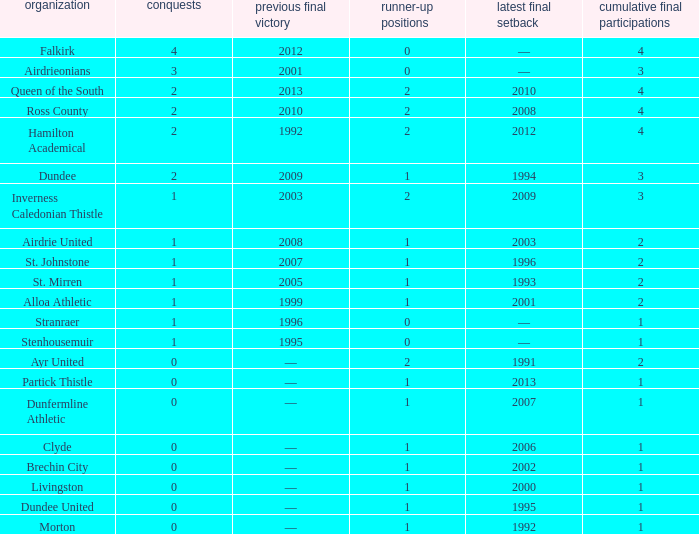What club has over 1 runners-up and last won the final in 2010? Ross County. 